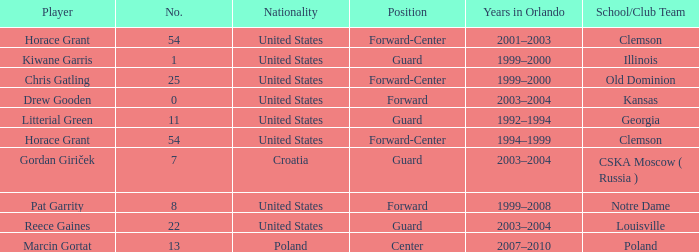What number identifies Chris Gatling? 25.0. 